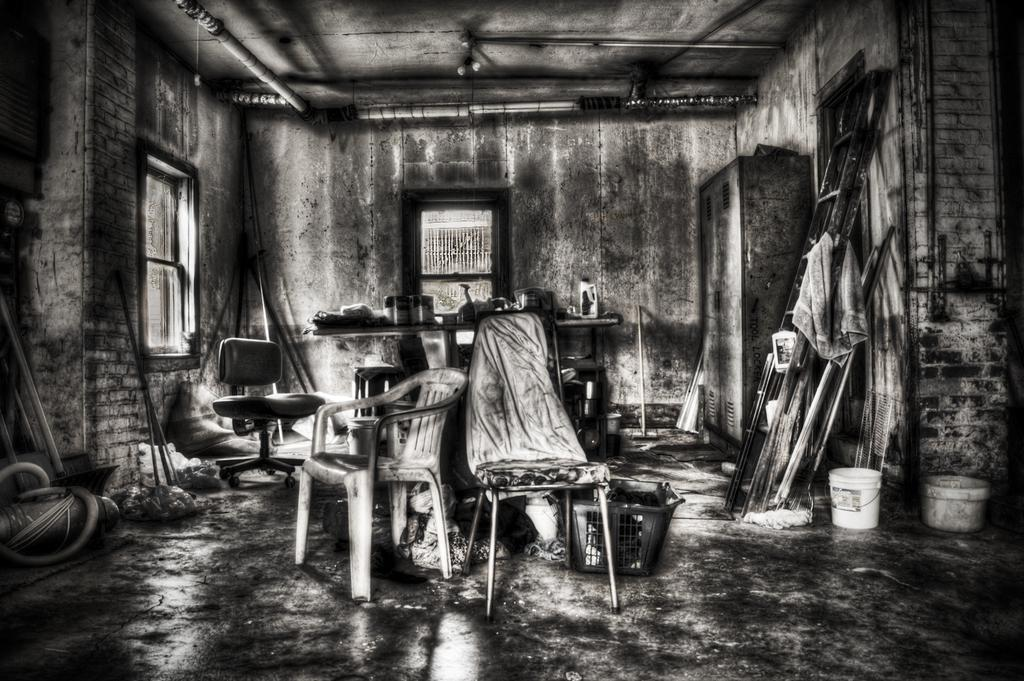What type of furniture can be seen in the image? There are chairs in the image. What object is located on the right side of the image? There is a white color bucket on the right side of the image. What type of structures are visible in the image? There are walls visible in the image. What architectural feature allows natural light to enter the space? There are windows in the image. What type of fruit is being served on the beds in the image? There are no beds or fruit present in the image. Is the queen visible in the image? There is no queen present in the image. 